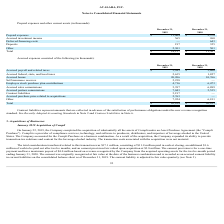According to Avalara's financial document, What does contract liabilities refer to? amounts that are collected in advance of the satisfaction of performance obligations under the new revenue recognition standard. The document states: "Contract liabilities represent amounts that are collected in advance of the satisfaction of performance obligations under the new revenue recognition ..." Also, Where are the relevant parts of the annual report pertaining to contract liabilities? Recently Adopted Accounting Standards in Note 2 and Contract Liabilities in Note 6.. The document states: "standard. See Recently Adopted Accounting Standards in Note 2 and Contract Liabilities in Note 6...." Also, What are the total accrued expenses in 2018 and 2019 respectively? The document shows two values: 42,101 and 62,104 (in thousands). From the document: "Total $ 62,104 $ 42,101 Total $ 62,104 $ 42,101..." Also, can you calculate: What is the percentage change in total accrued expenses between 2018 and 2019? To answer this question, I need to perform calculations using the financial data. The calculation is: (62,104 - 42,101)/42,101 , which equals 47.51 (percentage). This is based on the information: "Total $ 62,104 $ 42,101 Total $ 62,104 $ 42,101..." The key data points involved are: 42,101, 62,104. Also, can you calculate: What is the total accrued bonus in 2018 and 2019? Based on the calculation: 10,766 + 20,206 , the result is 30972 (in thousands). This is based on the information: "Accrued bonus 20,206 10,766 Accrued bonus 20,206 10,766..." The key data points involved are: 10,766, 20,206. Also, can you calculate: What is the value of the 2018 accrued bonus as a percentage of the 2018 total accrued expenses? Based on the calculation: 10,766/42,101 , the result is 25.57 (percentage). This is based on the information: "Total $ 62,104 $ 42,101 Accrued bonus 20,206 10,766..." The key data points involved are: 10,766, 42,101. 